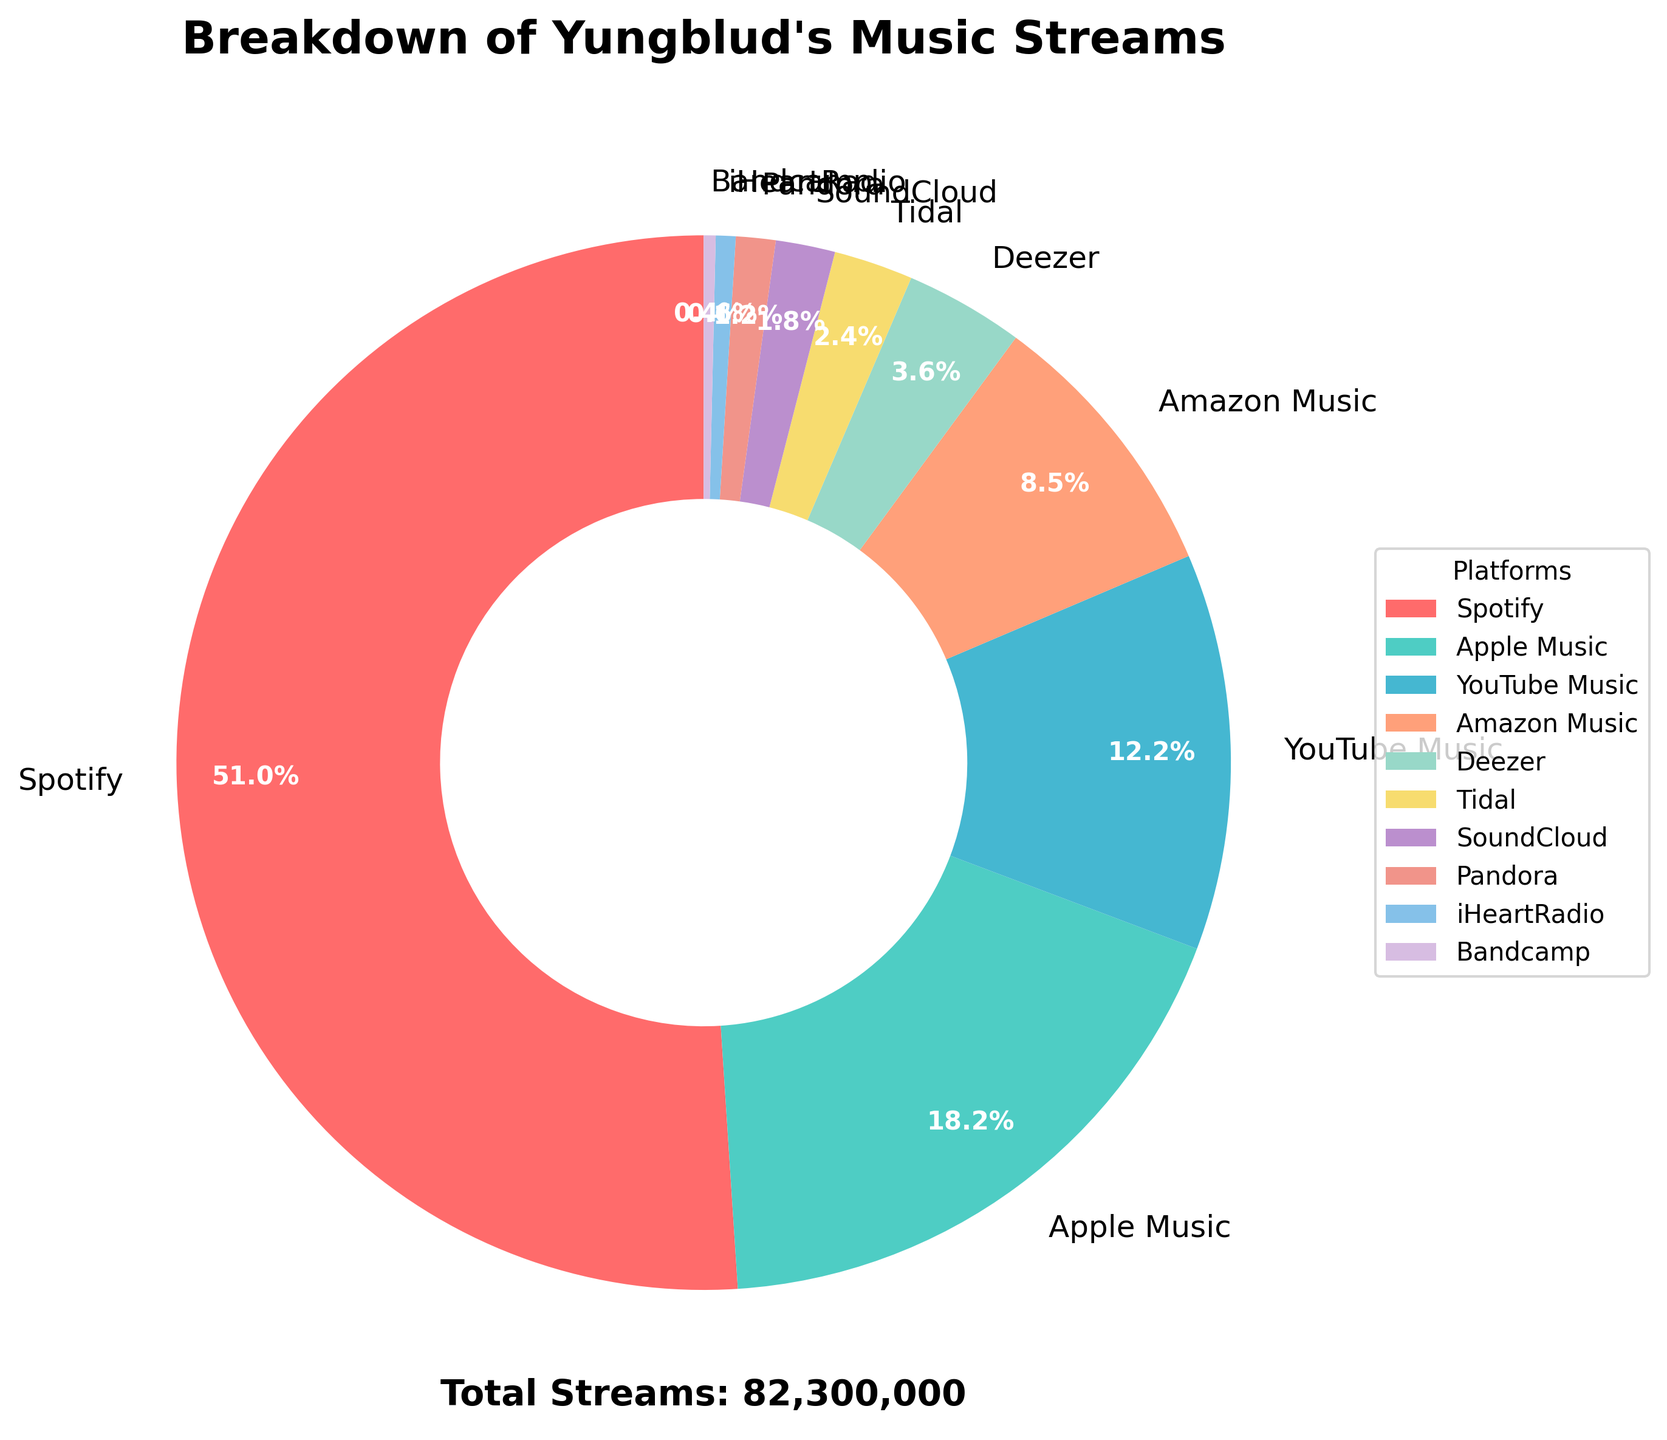Which platform has the highest percentage of streams? Start by visually inspecting the labeled percentages on the wedges of the pie chart. The largest wedge corresponds to Spotify, which has a label indicating 51.2% of the total streams.
Answer: Spotify What's the combined percentage of streams from Spotify and Apple Music? First, note the percentage allocation for Spotify (51.2%) and Apple Music (18.3%) from the chart. Add these two percentages together.
Answer: 69.5% Which platform has fewer streams: Deezer or Tidal? Compare the labeled percentages for Deezer (3.7%) and Tidal (2.4%) on the chart. Deezer has a larger percentage than Tidal, indicating that Tidal has fewer streams.
Answer: Tidal What is the approximate total number of streams on platforms other than Spotify? First, find the total number of streams (84,000,000). Then subtract the number of streams for Spotify (42,000,000) from this total.
Answer: 42,000,000 Are there more streams from YouTube Music or from Pandora, Deezer, and SoundCloud combined? Calculate the combined streams from Pandora (1,000,000), Deezer (3,000,000), and SoundCloud (1,500,000), which total to 5,500,000. Compare this with YouTube Music's streams (10,000,000) as labeled on the chart. YouTube Music's streams are higher.
Answer: YouTube Music Which platform represents the smallest percentage of streams? Identify the smallest wedge in the pie chart, which corresponds to Bandcamp, labeled as 0.4%.
Answer: Bandcamp How much greater is the number of streams on Amazon Music compared to iHeartRadio? From the data, Amazon Music has 7,000,000 streams and iHeartRadio has 500,000. Subtract the iHeartRadio streams from Amazon Music streams.
Answer: 6,500,000 What is the percentage difference between streams on Spotify (the largest platform) and Tidal (the smallest platform)? Spotify accounts for 51.2% of the streams and Tidal accounts for 2.4%. Subtract Tidal's percentage from Spotify's percentage to find the difference.
Answer: 48.8% Which platform has a percentage closest to that of Apple Music's streams? Apple Music has 18.3% of the streams. Locate the percentage of other platforms and find the closest one, which is YouTube Music with 11.9%.
Answer: YouTube Music 